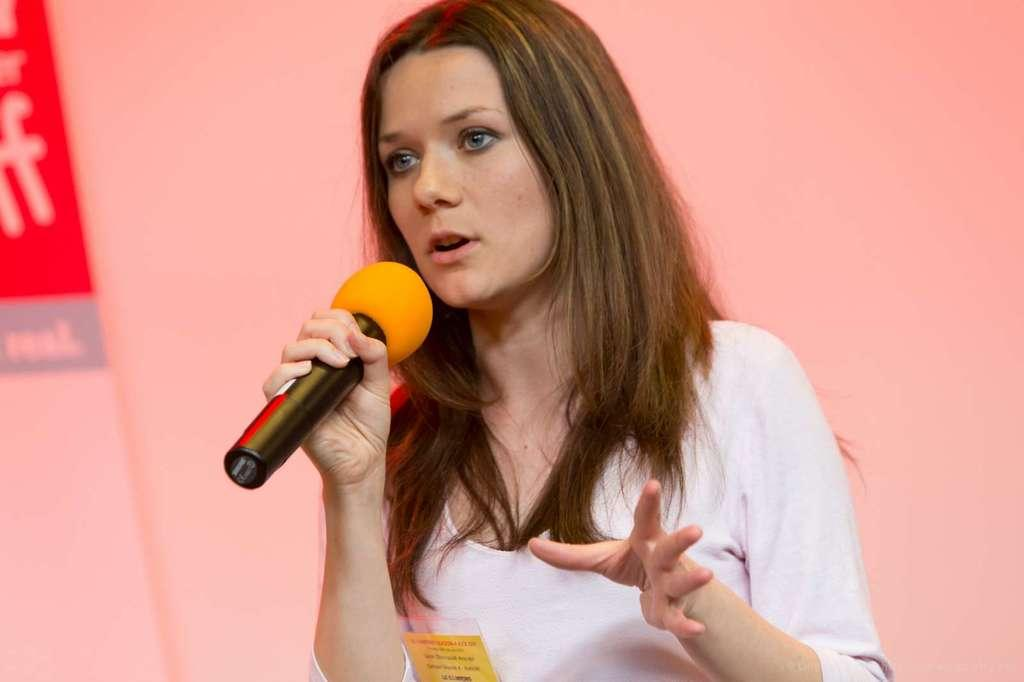Who is the main subject in the picture? There is a woman in the picture. What is the woman holding in her right hand? The woman is holding a microphone in her right hand. What is the woman doing with the microphone? The woman is speaking. What type of oranges can be seen in the image? There are no oranges present in the image. How does the woman use the wax to improve her speech? There is no wax mentioned in the image, and the woman is already speaking without any apparent need for wax. 